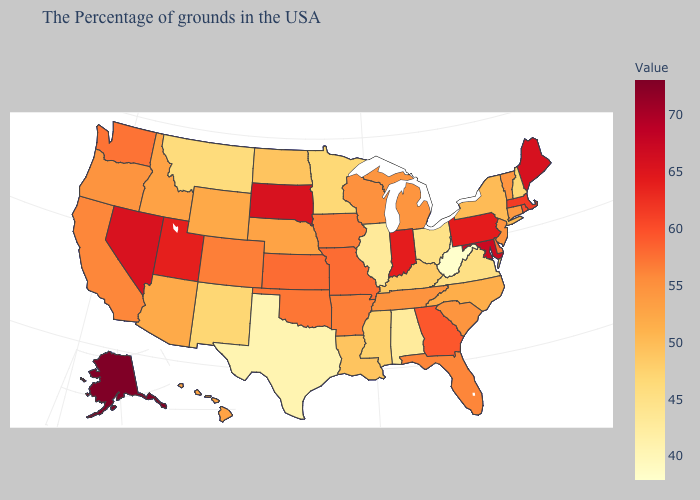Which states have the lowest value in the USA?
Give a very brief answer. West Virginia. Which states hav the highest value in the West?
Give a very brief answer. Alaska. Which states have the highest value in the USA?
Be succinct. Alaska. Does Iowa have the highest value in the USA?
Write a very short answer. No. Which states have the lowest value in the USA?
Be succinct. West Virginia. 